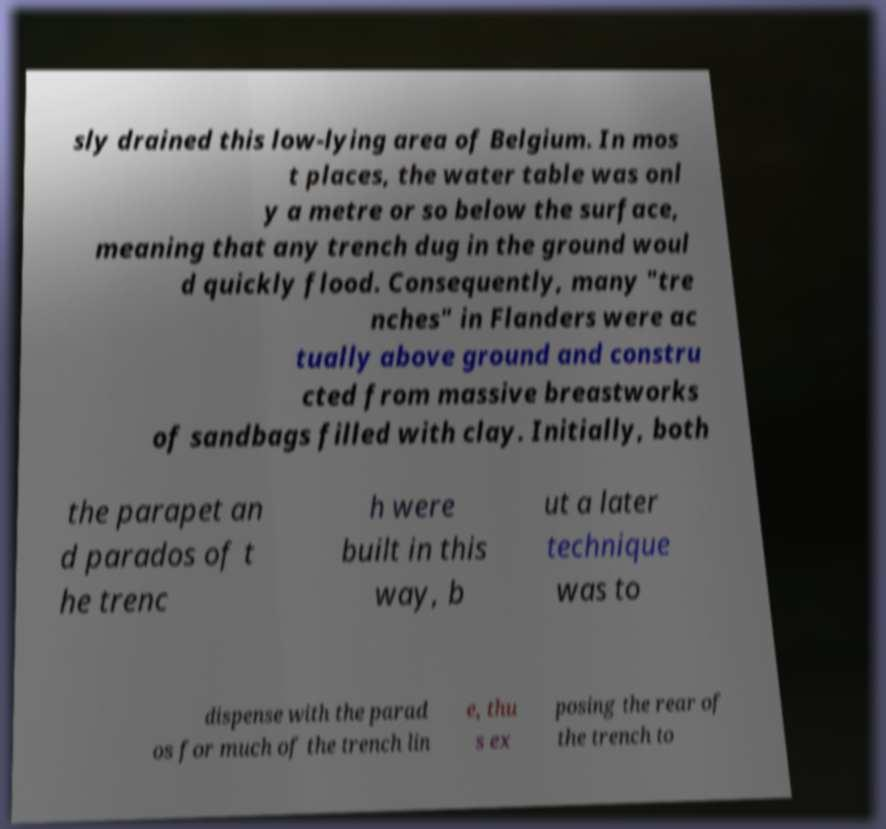I need the written content from this picture converted into text. Can you do that? sly drained this low-lying area of Belgium. In mos t places, the water table was onl y a metre or so below the surface, meaning that any trench dug in the ground woul d quickly flood. Consequently, many "tre nches" in Flanders were ac tually above ground and constru cted from massive breastworks of sandbags filled with clay. Initially, both the parapet an d parados of t he trenc h were built in this way, b ut a later technique was to dispense with the parad os for much of the trench lin e, thu s ex posing the rear of the trench to 